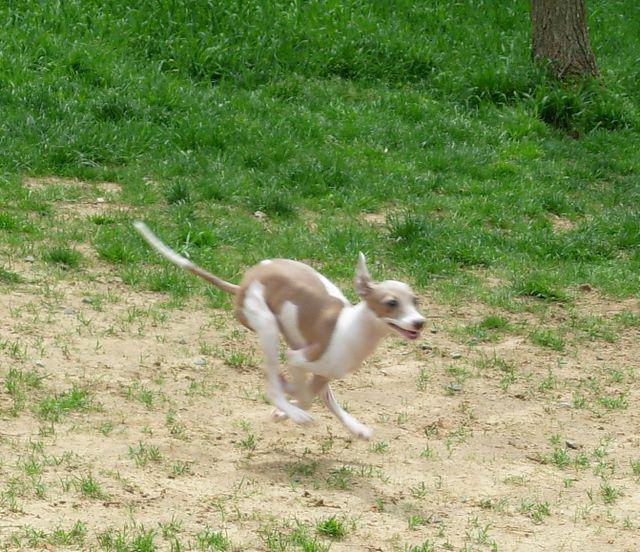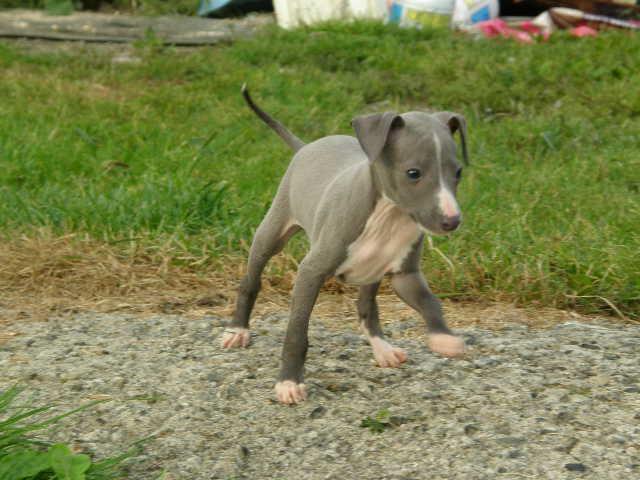The first image is the image on the left, the second image is the image on the right. Given the left and right images, does the statement "There are at least three mammals in total." hold true? Answer yes or no. No. The first image is the image on the left, the second image is the image on the right. Assess this claim about the two images: "The combined images include two dogs in motion, and no images show a human with a dog.". Correct or not? Answer yes or no. Yes. 